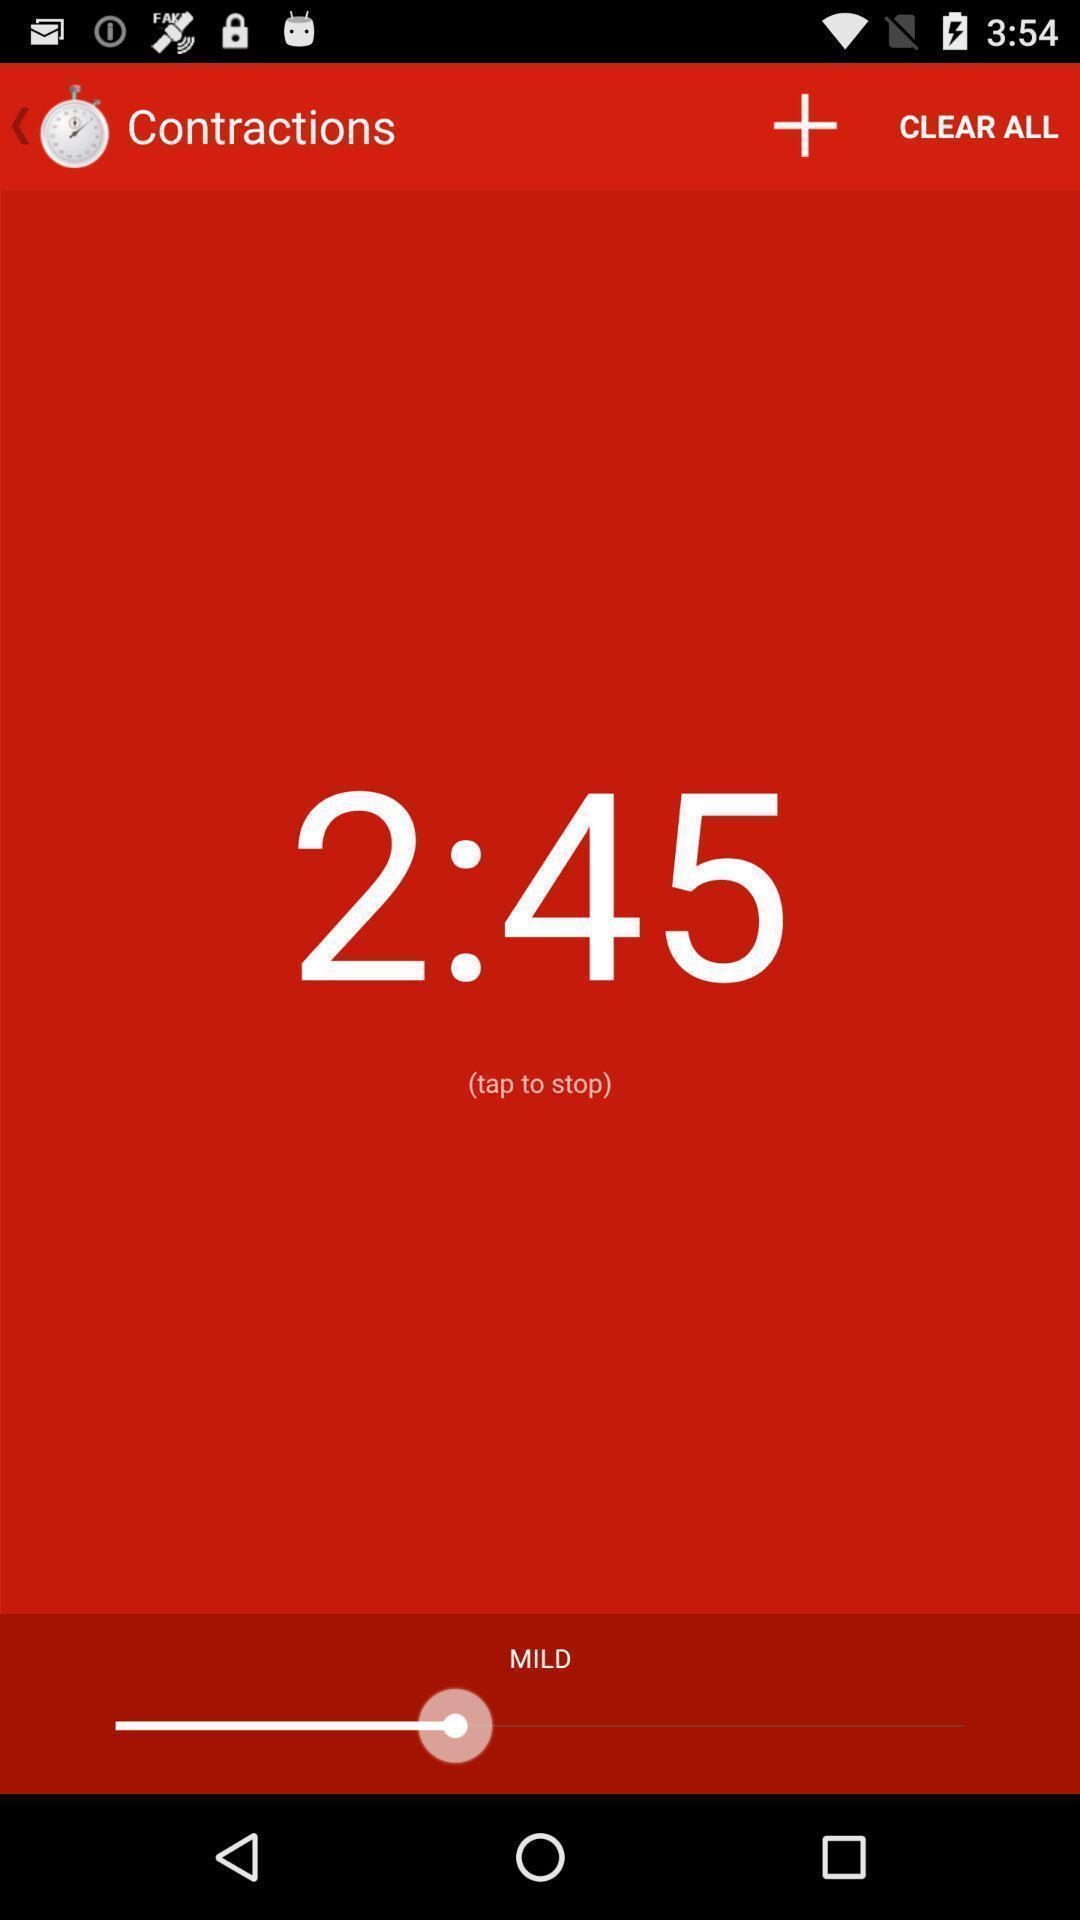Describe the visual elements of this screenshot. Timer is showing on contractions page. 